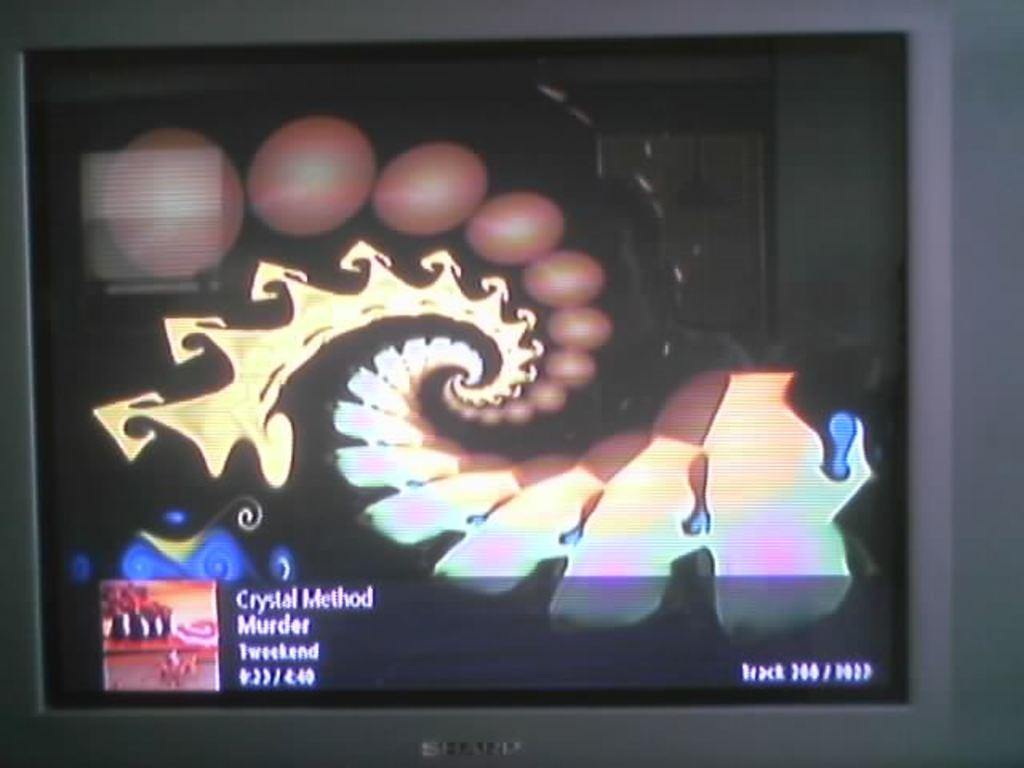<image>
Offer a succinct explanation of the picture presented. A screen displays a music video for Crystal Method's song Murder. 